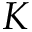Convert formula to latex. <formula><loc_0><loc_0><loc_500><loc_500>K</formula> 